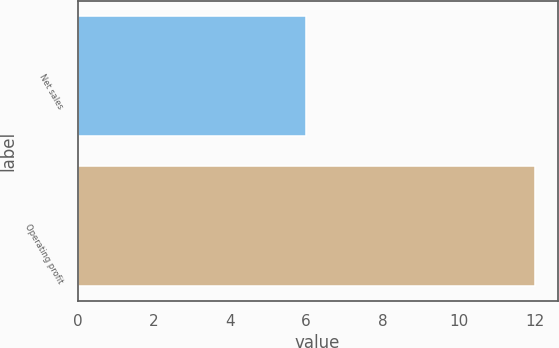Convert chart. <chart><loc_0><loc_0><loc_500><loc_500><bar_chart><fcel>Net sales<fcel>Operating profit<nl><fcel>6<fcel>12<nl></chart> 